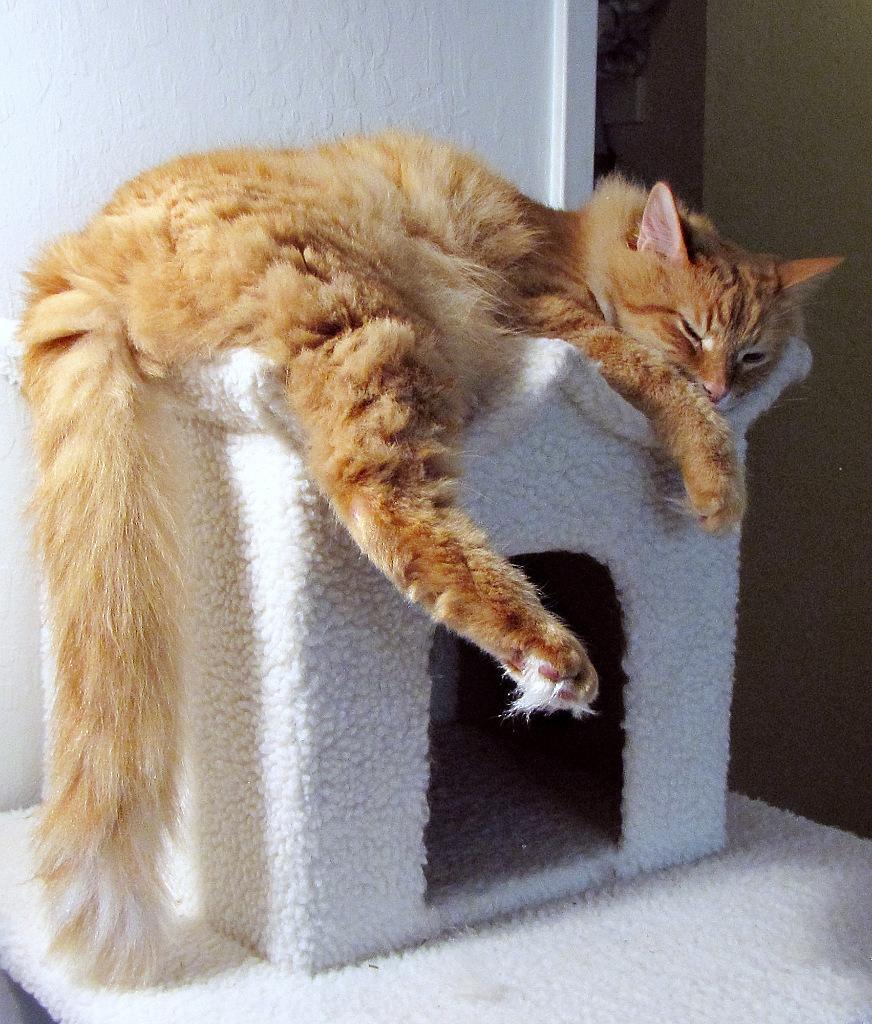Could you give a brief overview of what you see in this image? In this image we can see a cat lying on the pet house. In the background we can see walls. 